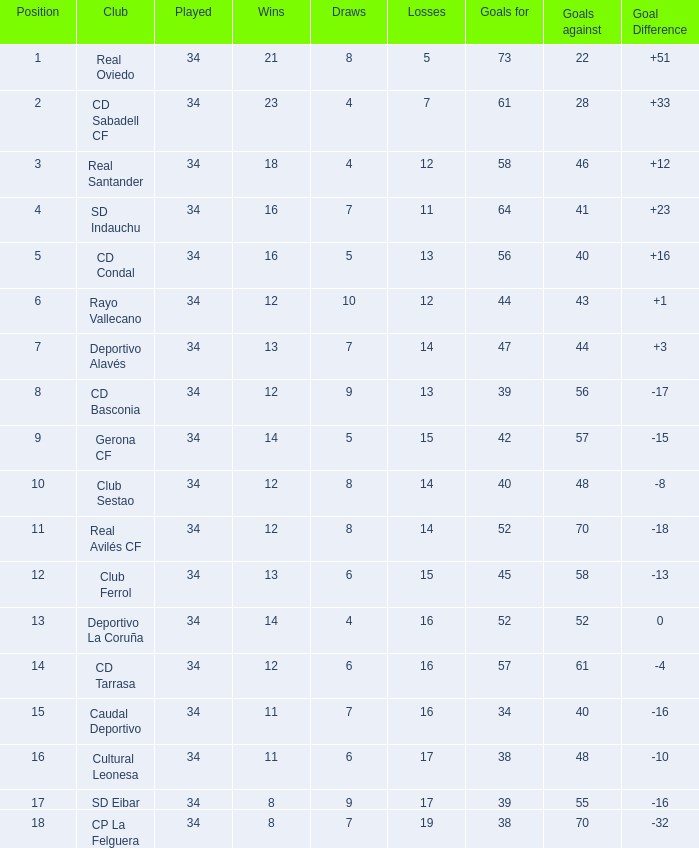Which successes have a goal spread above 0, and goals opposed over 40, and a position beneath 6, and a team of sd indauchu? 16.0. 